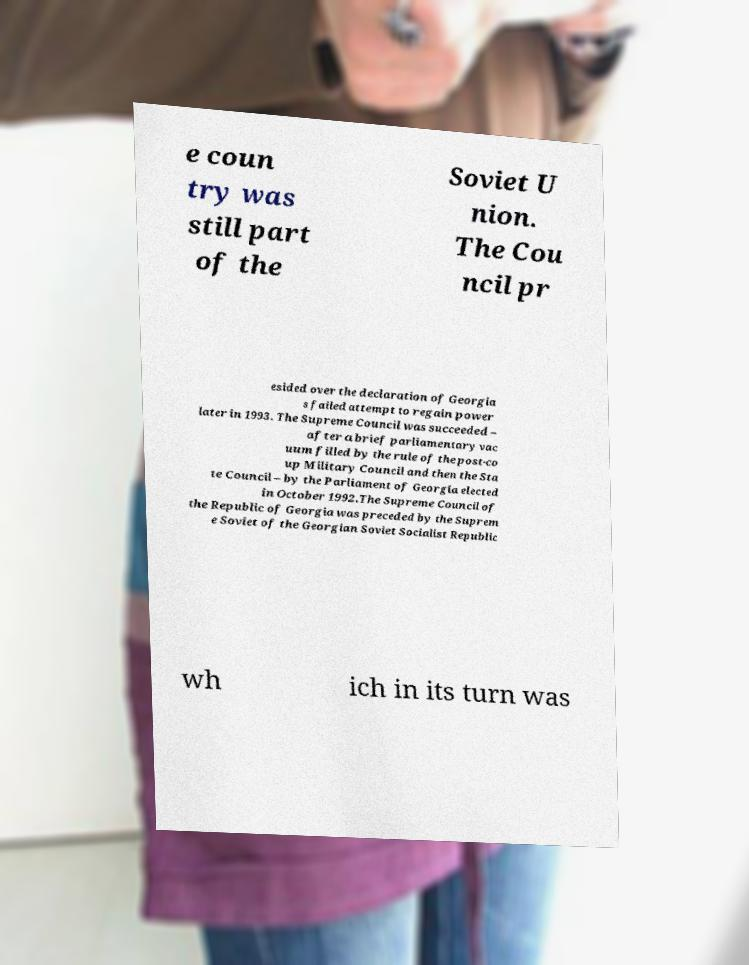Can you accurately transcribe the text from the provided image for me? e coun try was still part of the Soviet U nion. The Cou ncil pr esided over the declaration of Georgia s failed attempt to regain power later in 1993. The Supreme Council was succeeded – after a brief parliamentary vac uum filled by the rule of the post-co up Military Council and then the Sta te Council – by the Parliament of Georgia elected in October 1992.The Supreme Council of the Republic of Georgia was preceded by the Suprem e Soviet of the Georgian Soviet Socialist Republic wh ich in its turn was 